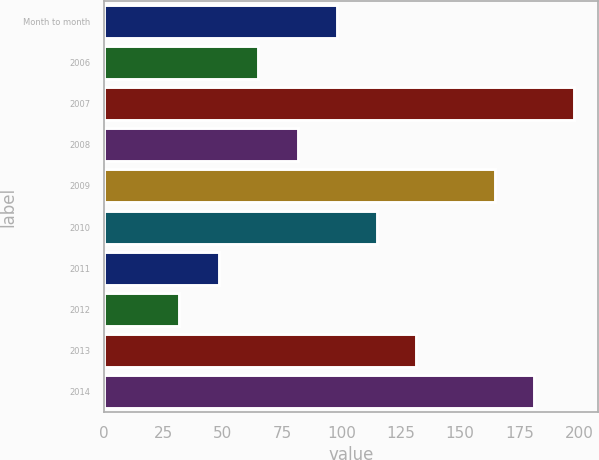Convert chart to OTSL. <chart><loc_0><loc_0><loc_500><loc_500><bar_chart><fcel>Month to month<fcel>2006<fcel>2007<fcel>2008<fcel>2009<fcel>2010<fcel>2011<fcel>2012<fcel>2013<fcel>2014<nl><fcel>98.32<fcel>65.08<fcel>198<fcel>81.7<fcel>164.56<fcel>114.94<fcel>48.46<fcel>31.84<fcel>131.56<fcel>181.18<nl></chart> 